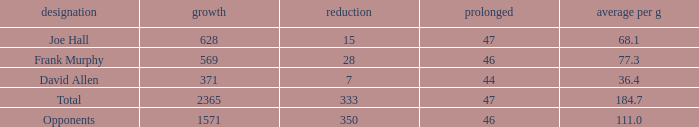Which Avg/G is the lowest one that has a Long smaller than 47, and a Name of frank murphy, and a Gain smaller than 569? None. 